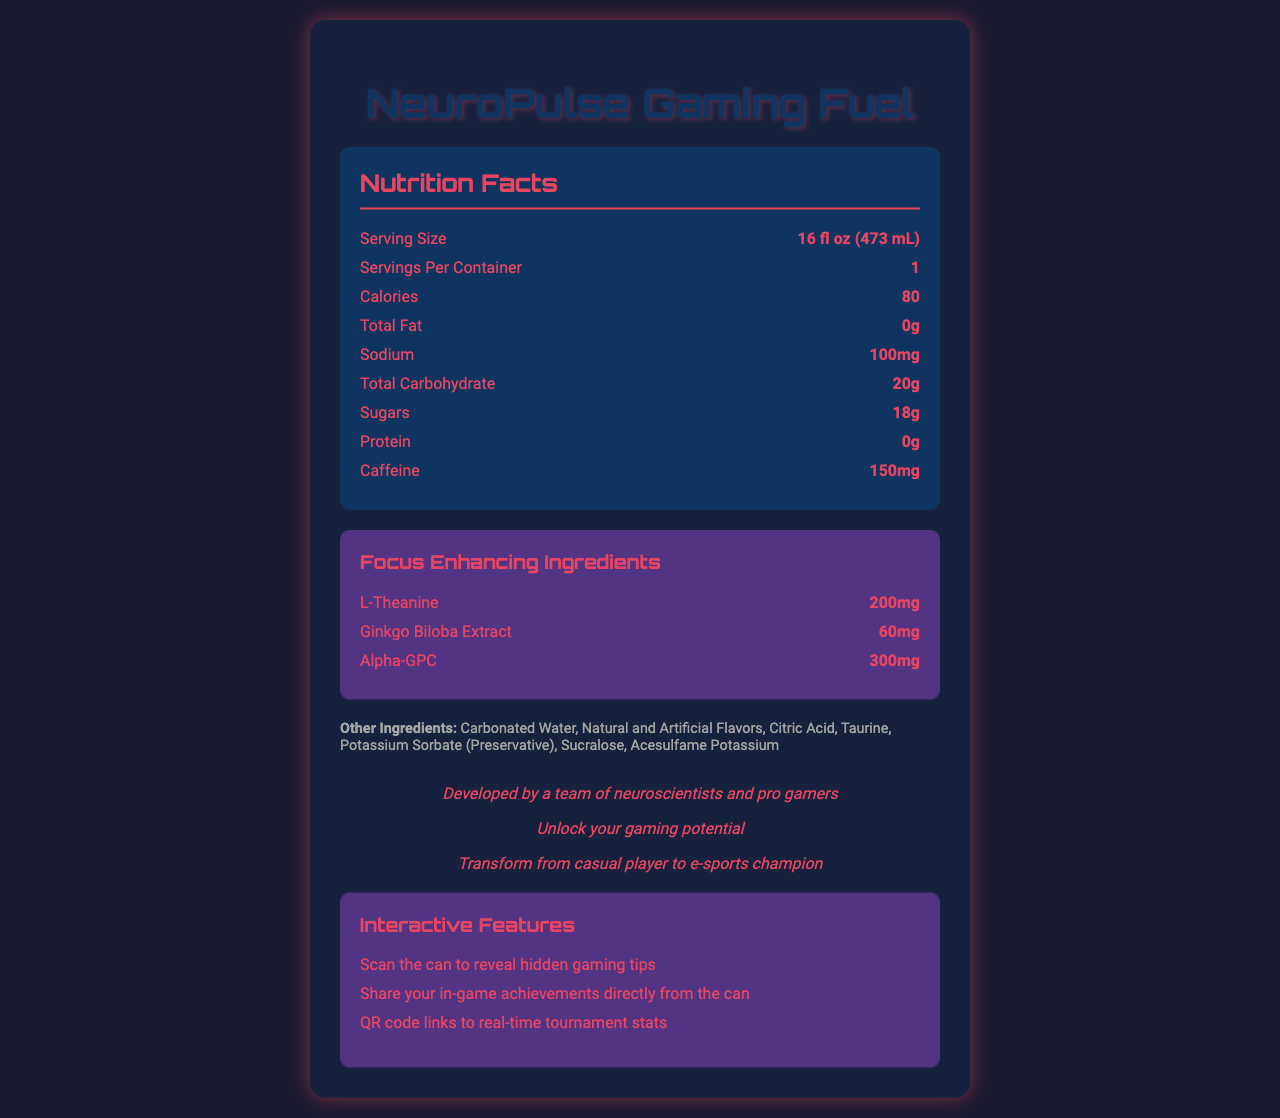what is the serving size? The serving size is explicitly mentioned in the Nutrition Facts section as 16 fl oz (473 mL).
Answer: 16 fl oz (473 mL) how many servings are in each container? The Nutrition Facts label states that there is 1 serving per container.
Answer: 1 what is the total calorie count per serving? The total calorie count per serving is listed as 80 calories in the Nutrition Facts section.
Answer: 80 calories how much caffeine is in one serving? The amount of caffeine per serving is indicated to be 150mg in the Nutrition Facts section.
Answer: 150mg identify three focus-enhancing ingredients included in the product. The listed focus-enhancing ingredients are L-Theanine (200mg), Ginkgo Biloba Extract (60mg), and Alpha-GPC (300mg).
Answer: L-Theanine, Ginkgo Biloba Extract, Alpha-GPC how much sodium is in one serving? The sodium content per serving is listed as 100mg in the Nutrition Facts section.
Answer: 100mg how much Vitamin B12 is in one serving and what is its daily value percentage? A. 2mg, 50% B. 4mg, 50% C. 6mcg, 100% D. 150mg, 200% The document lists Vitamin B12 as containing 6mcg per serving with a daily value percentage of 100%.
Answer: C what does the augmented reality feature allow you to do? A. Play a mini-game B. Scan the can to reveal hidden gaming tips C. Earn reward points The augmented reality feature allows you to scan the can to reveal hidden gaming tips, as detailed in the Interactive Features section.
Answer: B are there any proteins present in this energy drink? The Nutrition Facts state that the protein content is 0g, indicating no proteins present.
Answer: No summarize the main elements of this document. The document describes the nutritional content of "NeuroPulse Gaming Fuel" and its special ingredients aimed at enhancing focus. It also elaborates on the product's narrative elements and interactive features designed to engage and attract gamers.
Answer: The document provides a detailed Nutrition Facts label for NeuroPulse Gaming Fuel, an energy drink for gamers. It includes calorie counts, macronutrient information, caffeine content, and focus-enhancing ingredients such as L-Theanine, Ginkgo Biloba Extract, and Alpha-GPC. The document also highlights a narrative backstory, quest, and character arc, along with interactive features like augmented reality, social integration, and QR codes for real-time stats. who developed the NeuroPulse Gaming Fuel? Although the backstory mentions that it was developed by a team of neuroscientists and pro gamers, it does not provide specific details on the development team.
Answer: Cannot be determined 